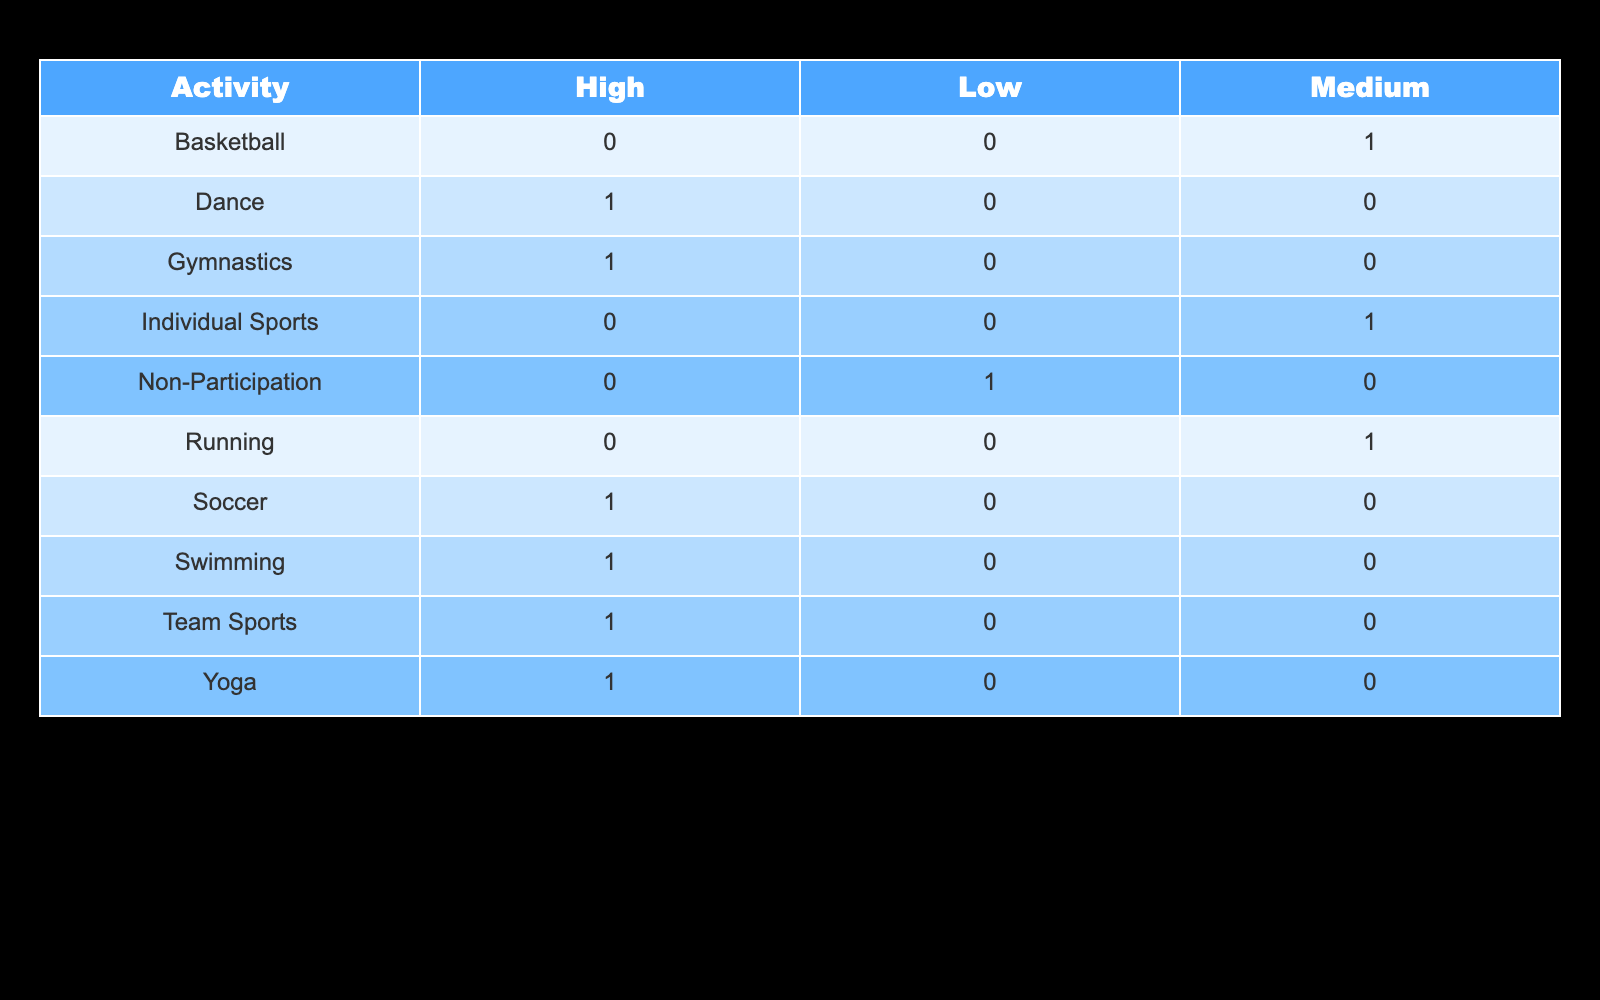What activity has the highest body image satisfaction level? According to the table, several activities are listed under the "High" body image satisfaction level. These include Soccer, Swimming, Gymnastics, Yoga, Team Sports, and Dance. Since the question asks for the single activity, any of these could be the answer; however, if looking for one, Soccer could be mentioned first based on standard listing.
Answer: Soccer How many activities are reported to have a medium body image satisfaction level? The table displays two activities characterized as having a medium body image satisfaction level: Basketball and Running. Counting these activities gives us a total of two.
Answer: 2 Is yoga associated with low body image satisfaction? Yoga is listed under the "High" body image satisfaction level in the table. Therefore, it is incorrect to say that yoga is associated with low body image satisfaction. The statement is false.
Answer: No What is the difference in the number of activities between high and low body image satisfaction levels? The table indicates that six activities are classified as having high body image satisfaction (Soccer, Swimming, Gymnastics, Yoga, Team Sports, Dance) and only one activity classified as low (Non-Participation). The difference is calculated as 6 - 1 = 5.
Answer: 5 Are individual sports more associated with body image satisfaction than team sports? Individual Sports is listed under medium body image satisfaction, while Team Sports is categorized under high body image satisfaction. Therefore, team sports are more associated with higher body image satisfaction than individual sports. The statement is false.
Answer: No What is the total count of activities mentioned in the table? The table lists a total of 9 activities: Soccer, Basketball, Swimming, Gymnastics, Running, Yoga, Team Sports, Individual Sports, Dance, and Non-Participation. Counting these gives a total of 9 activities present in the table.
Answer: 9 Which activity contributes to both medium and high body image satisfaction? In the table, there is no activity that contributes to both medium and high body image satisfaction. Each listed activity falls under a singular category of satisfaction, therefore this is not applicable. The statement is false.
Answer: No Which body image satisfaction level has the lowest representation in activities? By examining the table, it is evident that only one activity corresponds to the low body image satisfaction level (Non-Participation), while medium has two and high has six activities. Hence, low is indeed the least represented satisfaction level.
Answer: Low What is the average body image satisfaction level if we assign numerical values (High=3, Medium=2, Low=1) to each level based on the activities? To find the average, we will assign values based on the activities: High has 6 activities (3 points each), Medium has 2 activities (2 points each), and Low has 1 activity (1 point), leading to total satisfaction points of (6x3) + (2x2) + (1x1) = 18 + 4 + 1 = 23. The total count of activities is 9. Therefore, the average is calculated as 23 / 9 ≈ 2.56, which corresponds to the medium satisfaction level.
Answer: 2.56 